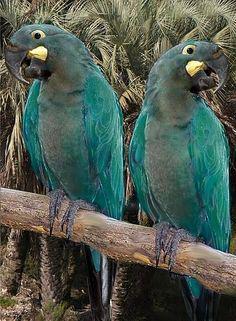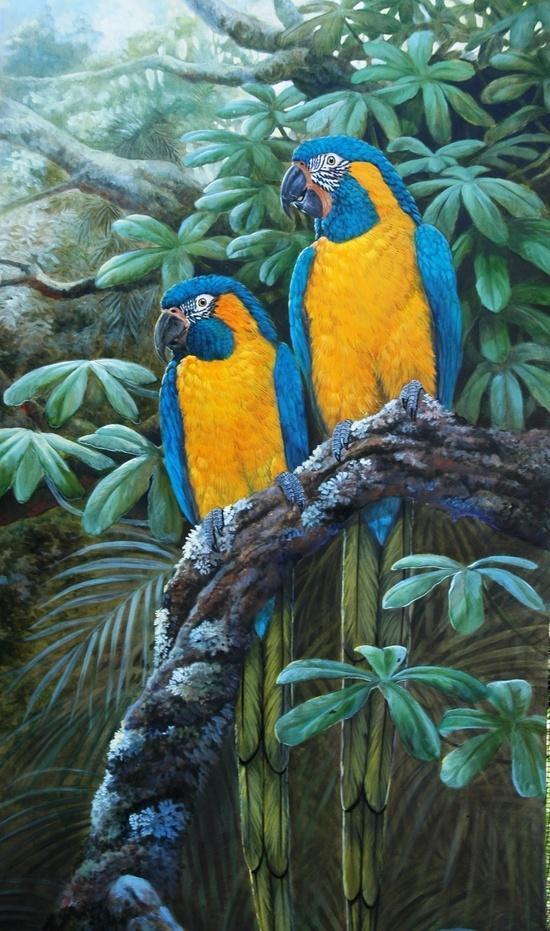The first image is the image on the left, the second image is the image on the right. For the images displayed, is the sentence "There are no less than four birds" factually correct? Answer yes or no. Yes. The first image is the image on the left, the second image is the image on the right. Evaluate the accuracy of this statement regarding the images: "The right and left images contain the same number of parrots.". Is it true? Answer yes or no. Yes. 